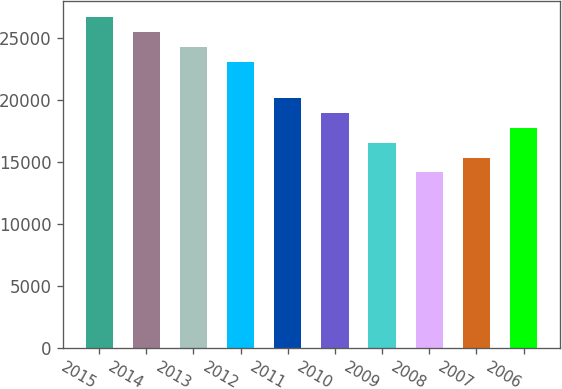Convert chart. <chart><loc_0><loc_0><loc_500><loc_500><bar_chart><fcel>2015<fcel>2014<fcel>2013<fcel>2012<fcel>2011<fcel>2010<fcel>2009<fcel>2008<fcel>2007<fcel>2006<nl><fcel>26686.7<fcel>25489.8<fcel>24292.9<fcel>23096<fcel>20175.5<fcel>18978.6<fcel>16584.8<fcel>14191<fcel>15387.9<fcel>17781.7<nl></chart> 